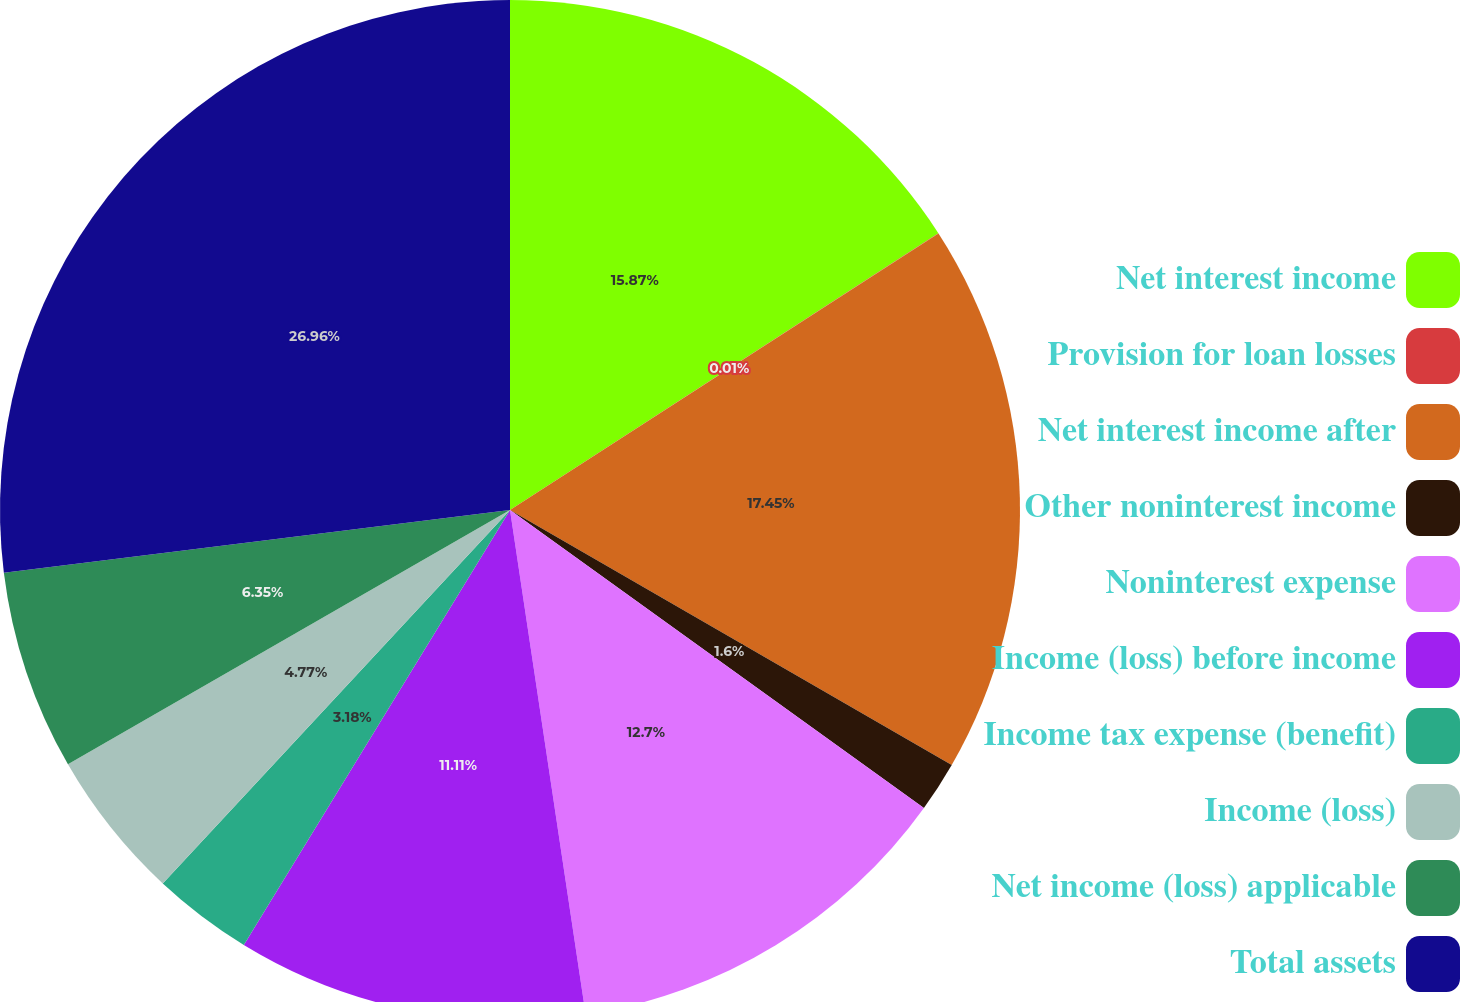<chart> <loc_0><loc_0><loc_500><loc_500><pie_chart><fcel>Net interest income<fcel>Provision for loan losses<fcel>Net interest income after<fcel>Other noninterest income<fcel>Noninterest expense<fcel>Income (loss) before income<fcel>Income tax expense (benefit)<fcel>Income (loss)<fcel>Net income (loss) applicable<fcel>Total assets<nl><fcel>15.87%<fcel>0.01%<fcel>17.45%<fcel>1.6%<fcel>12.7%<fcel>11.11%<fcel>3.18%<fcel>4.77%<fcel>6.35%<fcel>26.96%<nl></chart> 